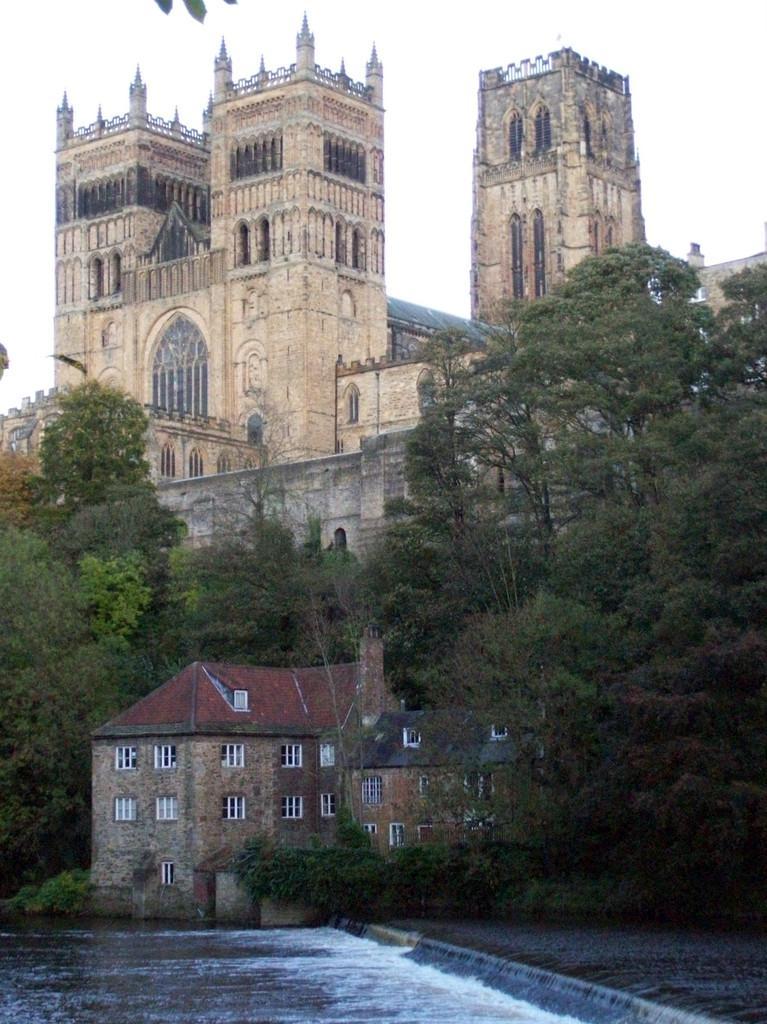Describe this image in one or two sentences. In this picture, it is called as a "Durham Cathedral". In front of durham cathedral, there are buildings, trees and water. At the top of the image, there is the sky. 